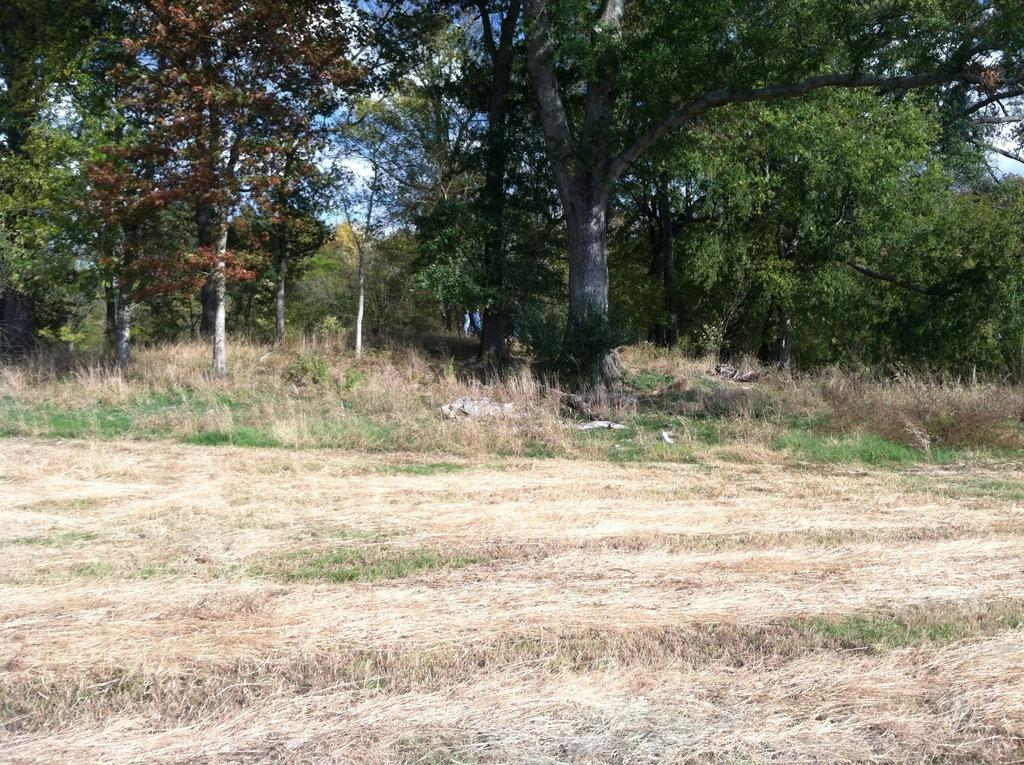What type of vegetation is present on the ground in the image? There is dried grass on the ground in the image. What other natural elements can be seen in the image? There are trees in the image. What is visible in the background of the image? The sky is visible in the background of the image. What can be observed in the sky? There are clouds in the sky. What color is the paint used to decorate the trees in the image? There is no paint or decoration on the trees in the image; they are natural trees. 